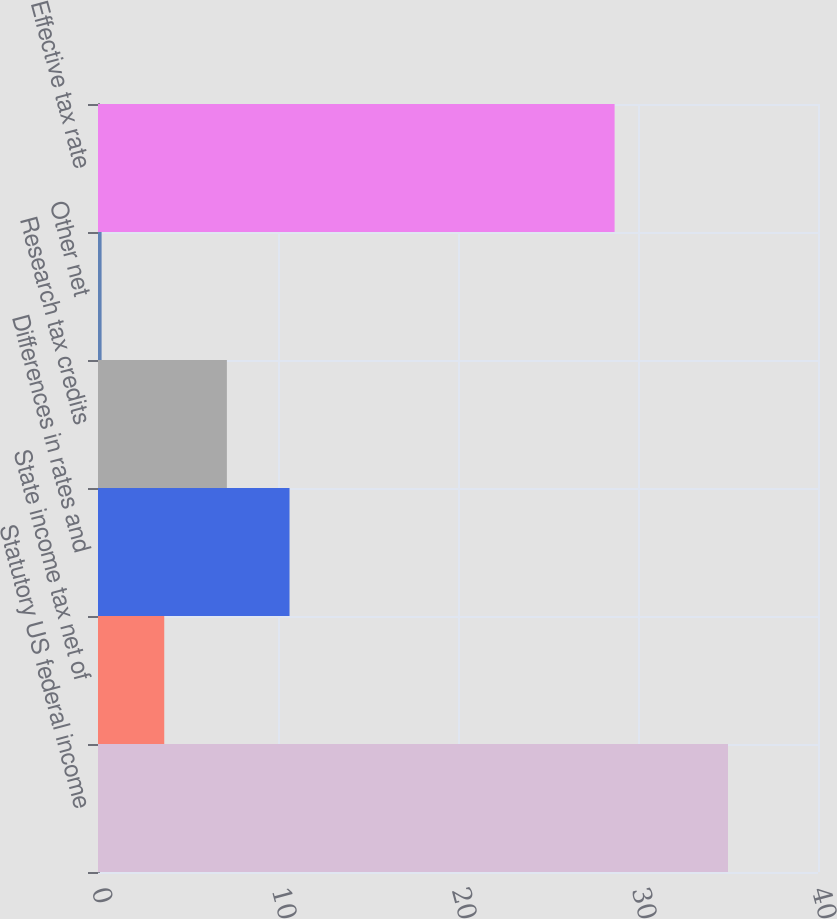Convert chart. <chart><loc_0><loc_0><loc_500><loc_500><bar_chart><fcel>Statutory US federal income<fcel>State income tax net of<fcel>Differences in rates and<fcel>Research tax credits<fcel>Other net<fcel>Effective tax rate<nl><fcel>35<fcel>3.68<fcel>10.64<fcel>7.16<fcel>0.2<fcel>28.7<nl></chart> 